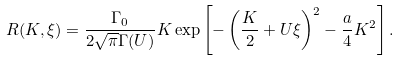<formula> <loc_0><loc_0><loc_500><loc_500>R ( K , \xi ) = \frac { \Gamma _ { 0 } } { 2 \sqrt { \pi } \Gamma ( U ) } K \exp \left [ - \left ( \frac { K } { 2 } + U \xi \right ) ^ { 2 } - \frac { a } { 4 } K ^ { 2 } \right ] .</formula> 